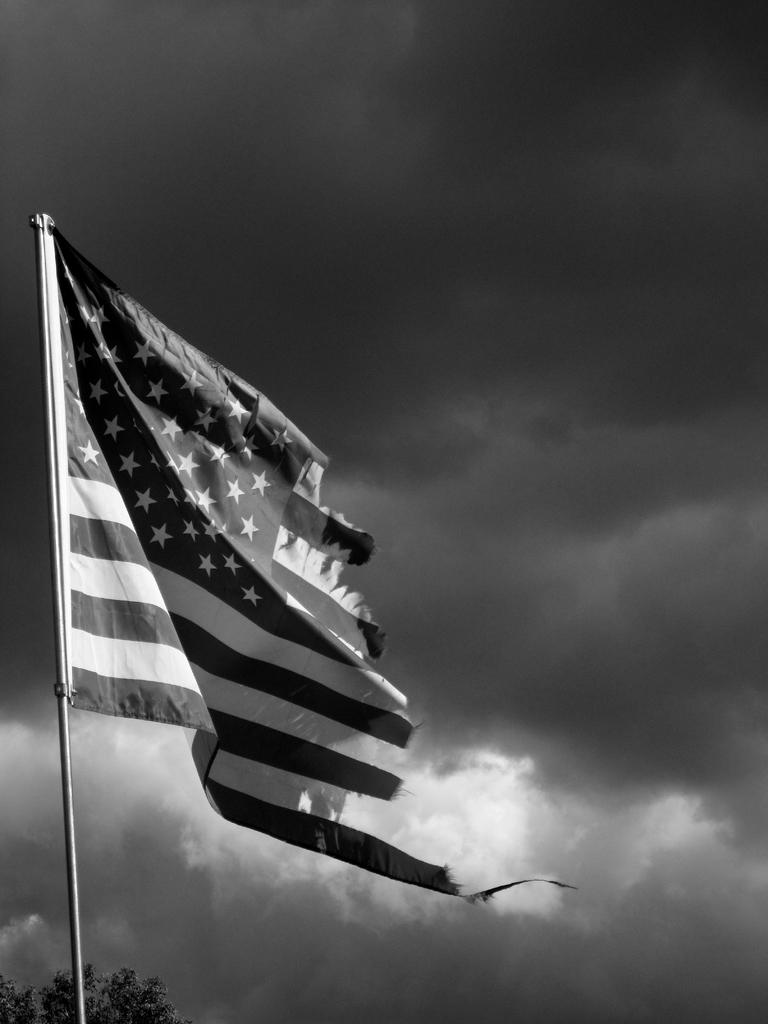What is the main object in the foreground of the image? There is a flag in the foreground of the image. What can be seen in the background of the image? There is a tree and the sky visible in the background of the image. How does the sky appear in the image? The sky appears to be cloudy in the image. What is the color scheme of the image? The image is black and white. What type of house can be seen in the background of the image? There is no house present in the image; it only features a flag, a tree, and the sky. How does the button help with digestion in the image? There is no button or reference to digestion in the image. 